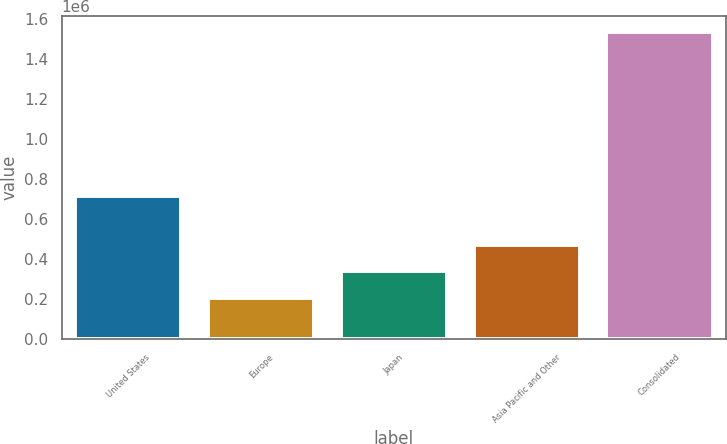Convert chart to OTSL. <chart><loc_0><loc_0><loc_500><loc_500><bar_chart><fcel>United States<fcel>Europe<fcel>Japan<fcel>Asia Pacific and Other<fcel>Consolidated<nl><fcel>714036<fcel>207071<fcel>339928<fcel>472785<fcel>1.53564e+06<nl></chart> 